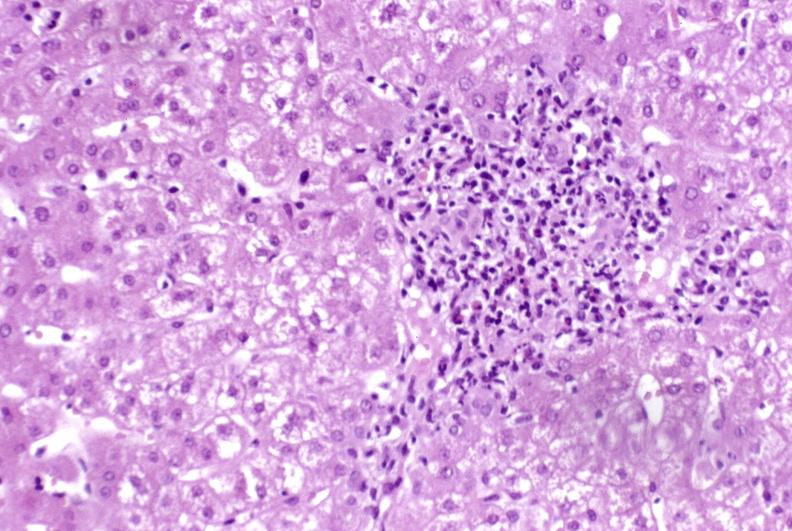what is present?
Answer the question using a single word or phrase. Liver 